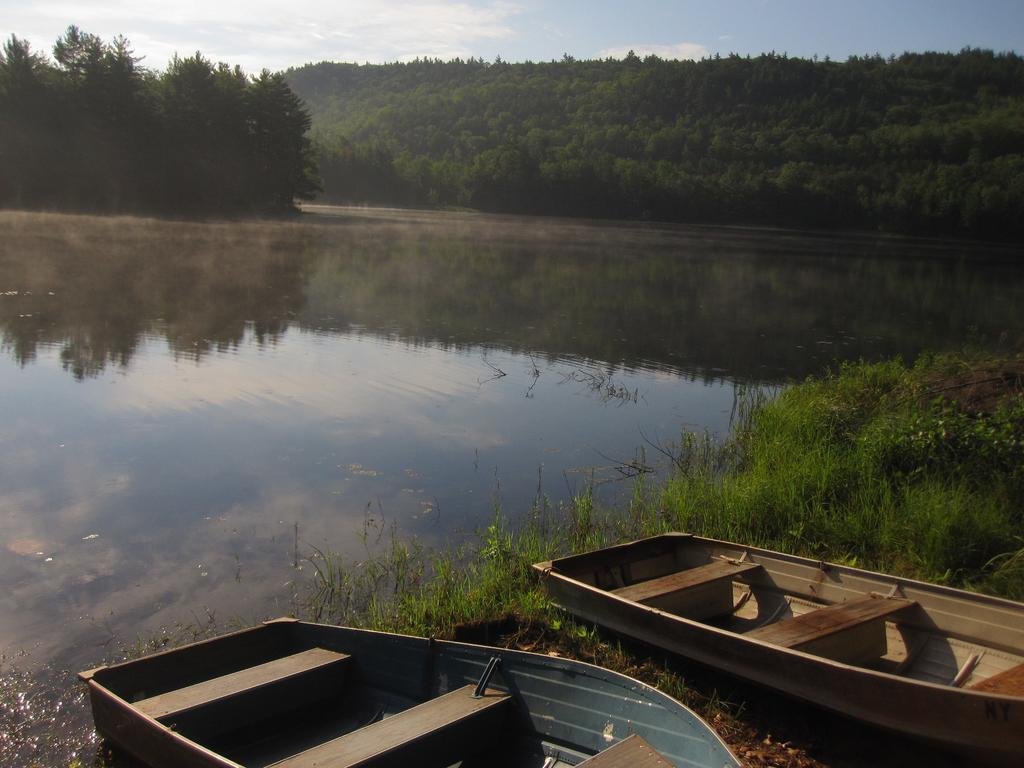What objects are on the ground in the image? There are boats on the ground in the image. What type of terrain is visible in the image? Grass is visible in the image. What body of water is present? There is a lake in the image. What type of vegetation is present in the image? Trees are present in the image. What is visible in the background of the image? The sky is visible in the image. What can be seen in the sky? Clouds are present in the sky. Where is the basketball court located in the image? There is no basketball court present in the image. What type of furniture can be seen in the image? There is no furniture, such as a sofa, present in the image. 